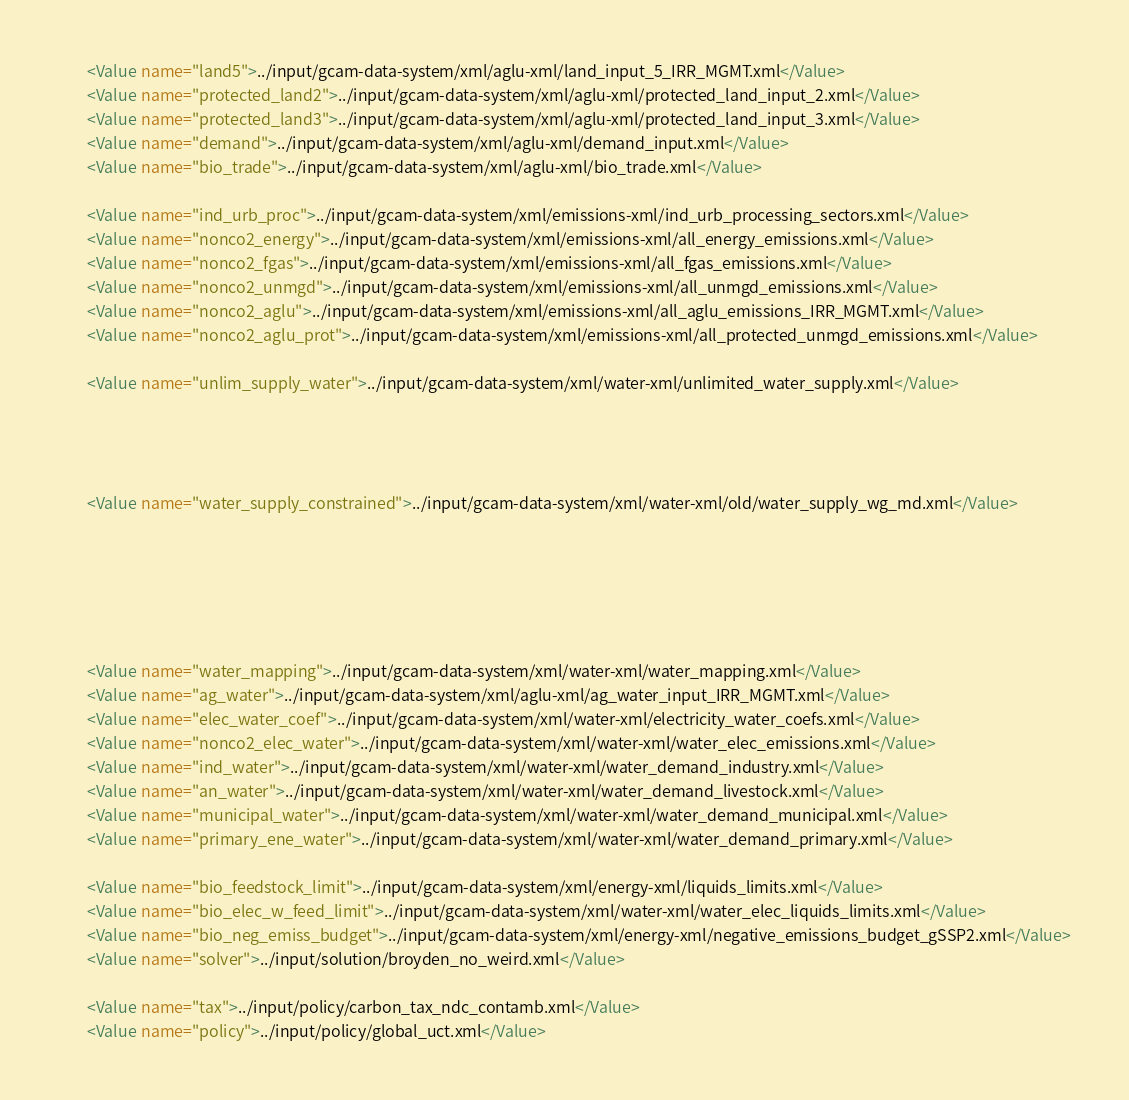Convert code to text. <code><loc_0><loc_0><loc_500><loc_500><_XML_>		<Value name="land5">../input/gcam-data-system/xml/aglu-xml/land_input_5_IRR_MGMT.xml</Value>
		<Value name="protected_land2">../input/gcam-data-system/xml/aglu-xml/protected_land_input_2.xml</Value>
		<Value name="protected_land3">../input/gcam-data-system/xml/aglu-xml/protected_land_input_3.xml</Value>
		<Value name="demand">../input/gcam-data-system/xml/aglu-xml/demand_input.xml</Value>
		<Value name="bio_trade">../input/gcam-data-system/xml/aglu-xml/bio_trade.xml</Value>

		<Value name="ind_urb_proc">../input/gcam-data-system/xml/emissions-xml/ind_urb_processing_sectors.xml</Value>
		<Value name="nonco2_energy">../input/gcam-data-system/xml/emissions-xml/all_energy_emissions.xml</Value>
		<Value name="nonco2_fgas">../input/gcam-data-system/xml/emissions-xml/all_fgas_emissions.xml</Value>
		<Value name="nonco2_unmgd">../input/gcam-data-system/xml/emissions-xml/all_unmgd_emissions.xml</Value>
		<Value name="nonco2_aglu">../input/gcam-data-system/xml/emissions-xml/all_aglu_emissions_IRR_MGMT.xml</Value>
		<Value name="nonco2_aglu_prot">../input/gcam-data-system/xml/emissions-xml/all_protected_unmgd_emissions.xml</Value>
		
		<Value name="unlim_supply_water">../input/gcam-data-system/xml/water-xml/unlimited_water_supply.xml</Value>
		
		
		
		
		<Value name="water_supply_constrained">../input/gcam-data-system/xml/water-xml/old/water_supply_wg_md.xml</Value>
		
		
		
		
		

		<Value name="water_mapping">../input/gcam-data-system/xml/water-xml/water_mapping.xml</Value>
		<Value name="ag_water">../input/gcam-data-system/xml/aglu-xml/ag_water_input_IRR_MGMT.xml</Value>
		<Value name="elec_water_coef">../input/gcam-data-system/xml/water-xml/electricity_water_coefs.xml</Value>
		<Value name="nonco2_elec_water">../input/gcam-data-system/xml/water-xml/water_elec_emissions.xml</Value>
		<Value name="ind_water">../input/gcam-data-system/xml/water-xml/water_demand_industry.xml</Value>
		<Value name="an_water">../input/gcam-data-system/xml/water-xml/water_demand_livestock.xml</Value>
		<Value name="municipal_water">../input/gcam-data-system/xml/water-xml/water_demand_municipal.xml</Value>
		<Value name="primary_ene_water">../input/gcam-data-system/xml/water-xml/water_demand_primary.xml</Value>

		<Value name="bio_feedstock_limit">../input/gcam-data-system/xml/energy-xml/liquids_limits.xml</Value>
		<Value name="bio_elec_w_feed_limit">../input/gcam-data-system/xml/water-xml/water_elec_liquids_limits.xml</Value>
		<Value name="bio_neg_emiss_budget">../input/gcam-data-system/xml/energy-xml/negative_emissions_budget_gSSP2.xml</Value>
		<Value name="solver">../input/solution/broyden_no_weird.xml</Value>
		
		<Value name="tax">../input/policy/carbon_tax_ndc_contamb.xml</Value>
		<Value name="policy">../input/policy/global_uct.xml</Value></code> 